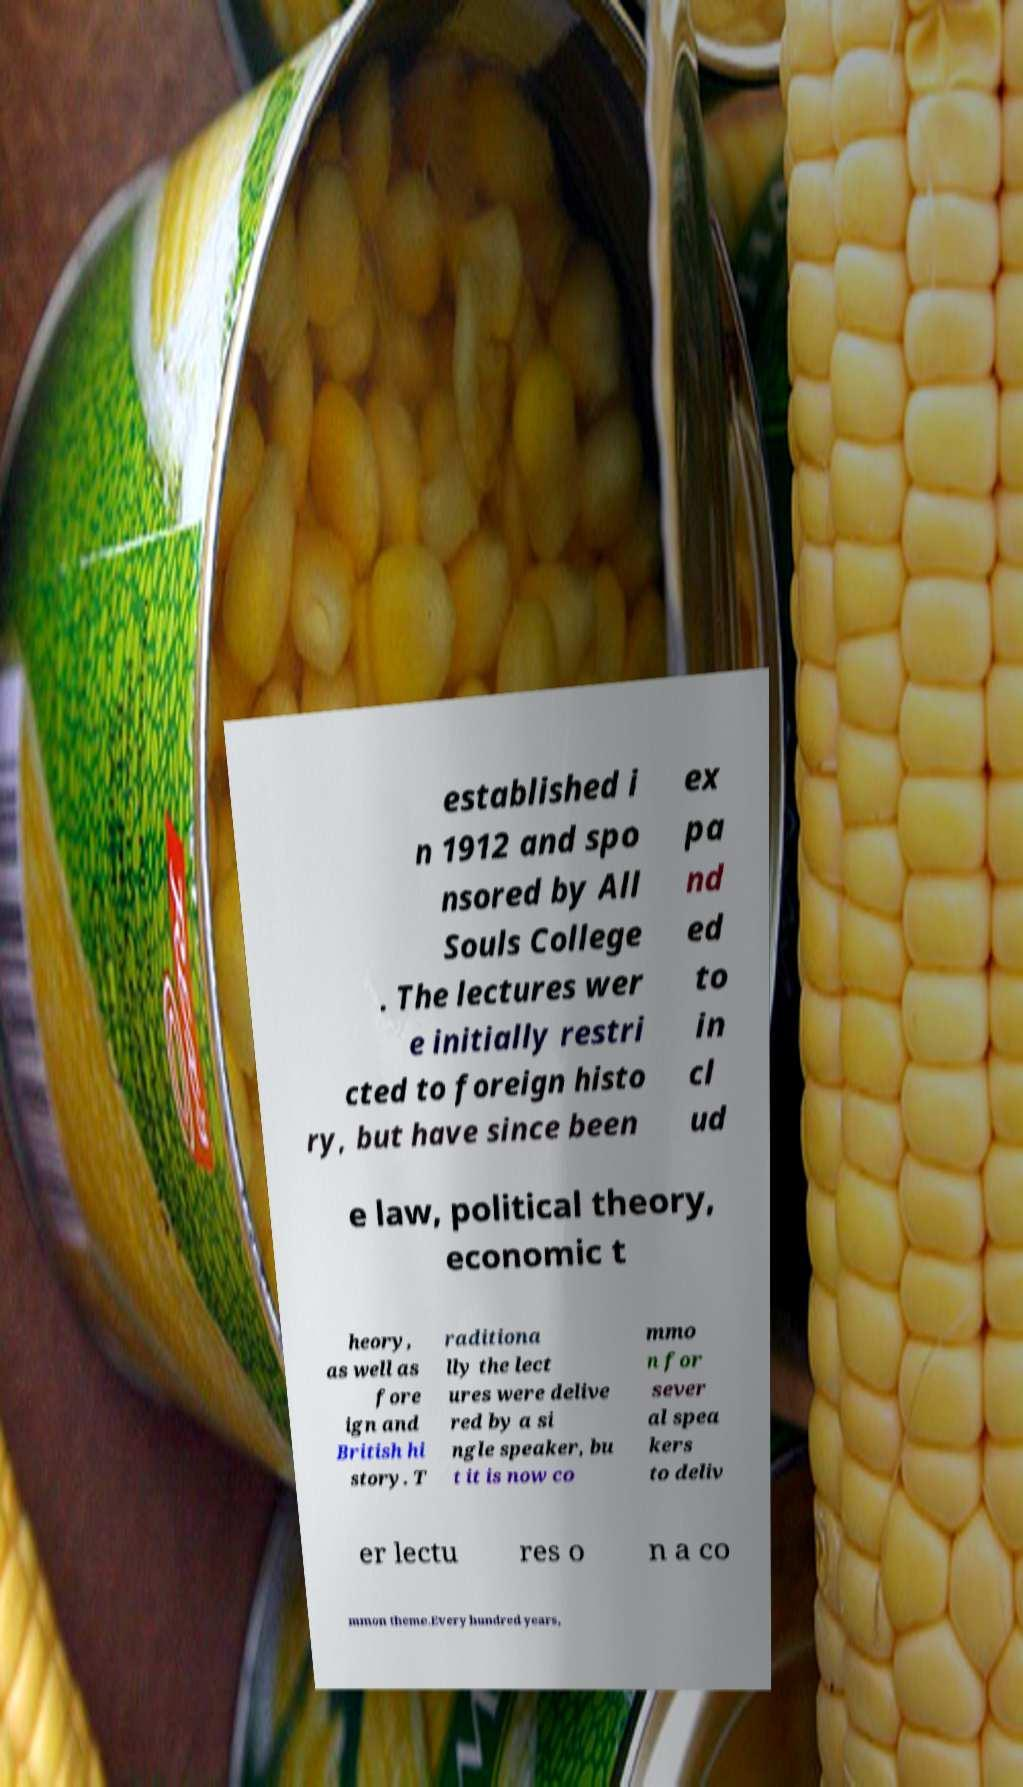Can you read and provide the text displayed in the image?This photo seems to have some interesting text. Can you extract and type it out for me? established i n 1912 and spo nsored by All Souls College . The lectures wer e initially restri cted to foreign histo ry, but have since been ex pa nd ed to in cl ud e law, political theory, economic t heory, as well as fore ign and British hi story. T raditiona lly the lect ures were delive red by a si ngle speaker, bu t it is now co mmo n for sever al spea kers to deliv er lectu res o n a co mmon theme.Every hundred years, 